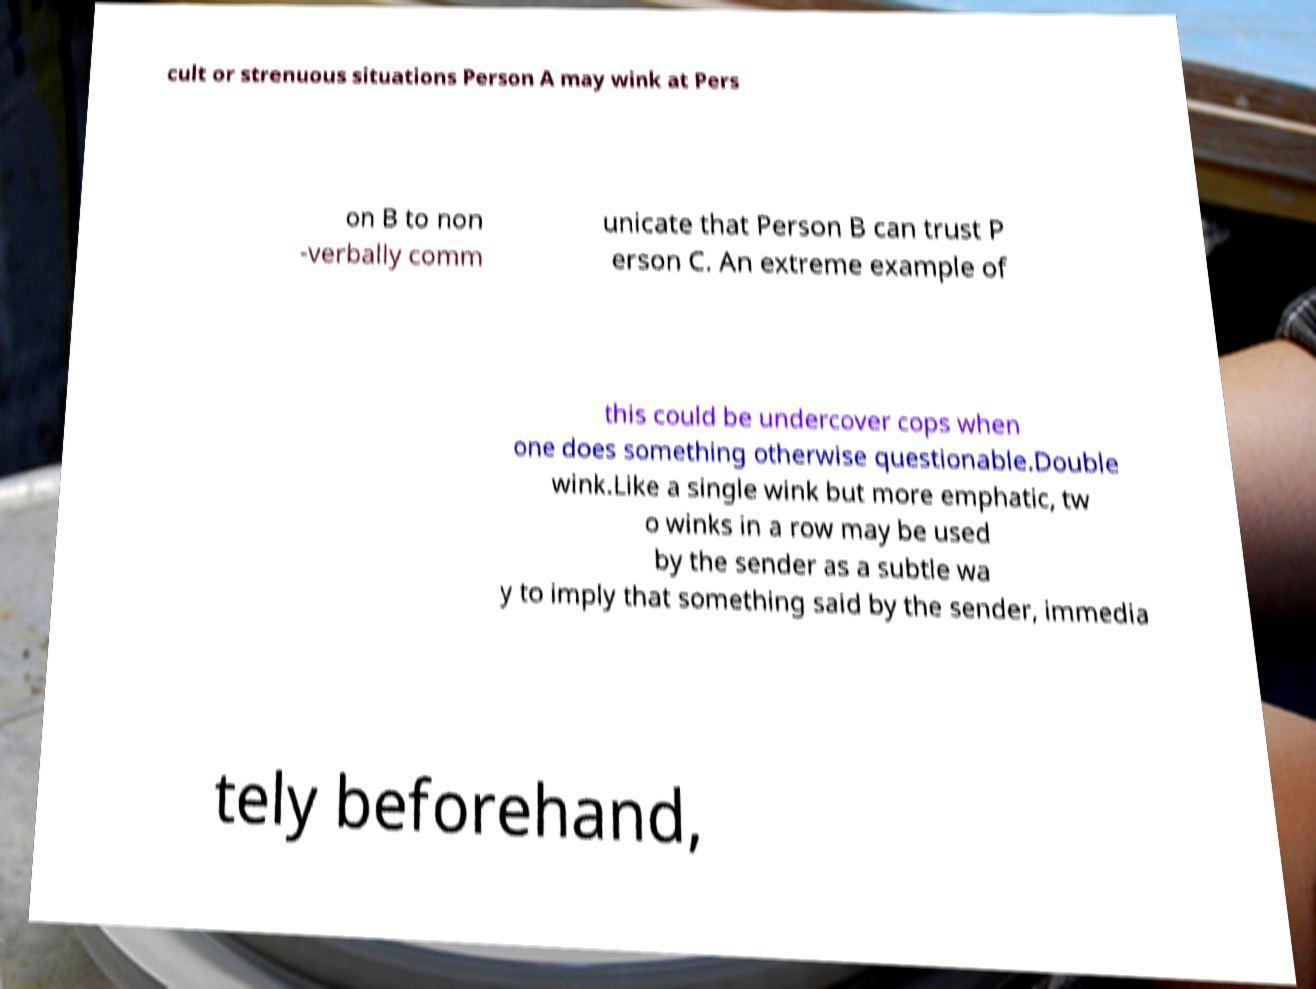I need the written content from this picture converted into text. Can you do that? cult or strenuous situations Person A may wink at Pers on B to non -verbally comm unicate that Person B can trust P erson C. An extreme example of this could be undercover cops when one does something otherwise questionable.Double wink.Like a single wink but more emphatic, tw o winks in a row may be used by the sender as a subtle wa y to imply that something said by the sender, immedia tely beforehand, 